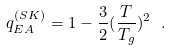<formula> <loc_0><loc_0><loc_500><loc_500>q _ { E A } ^ { ( S K ) } = 1 - \frac { 3 } { 2 } ( \frac { T } { T _ { g } } ) ^ { 2 } \ .</formula> 